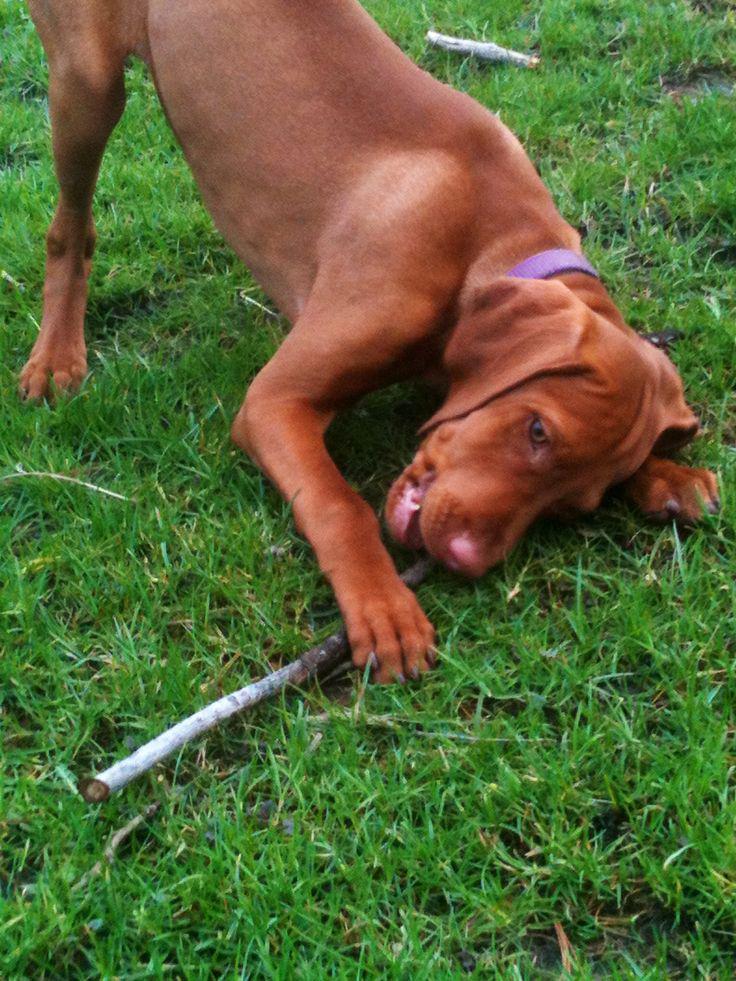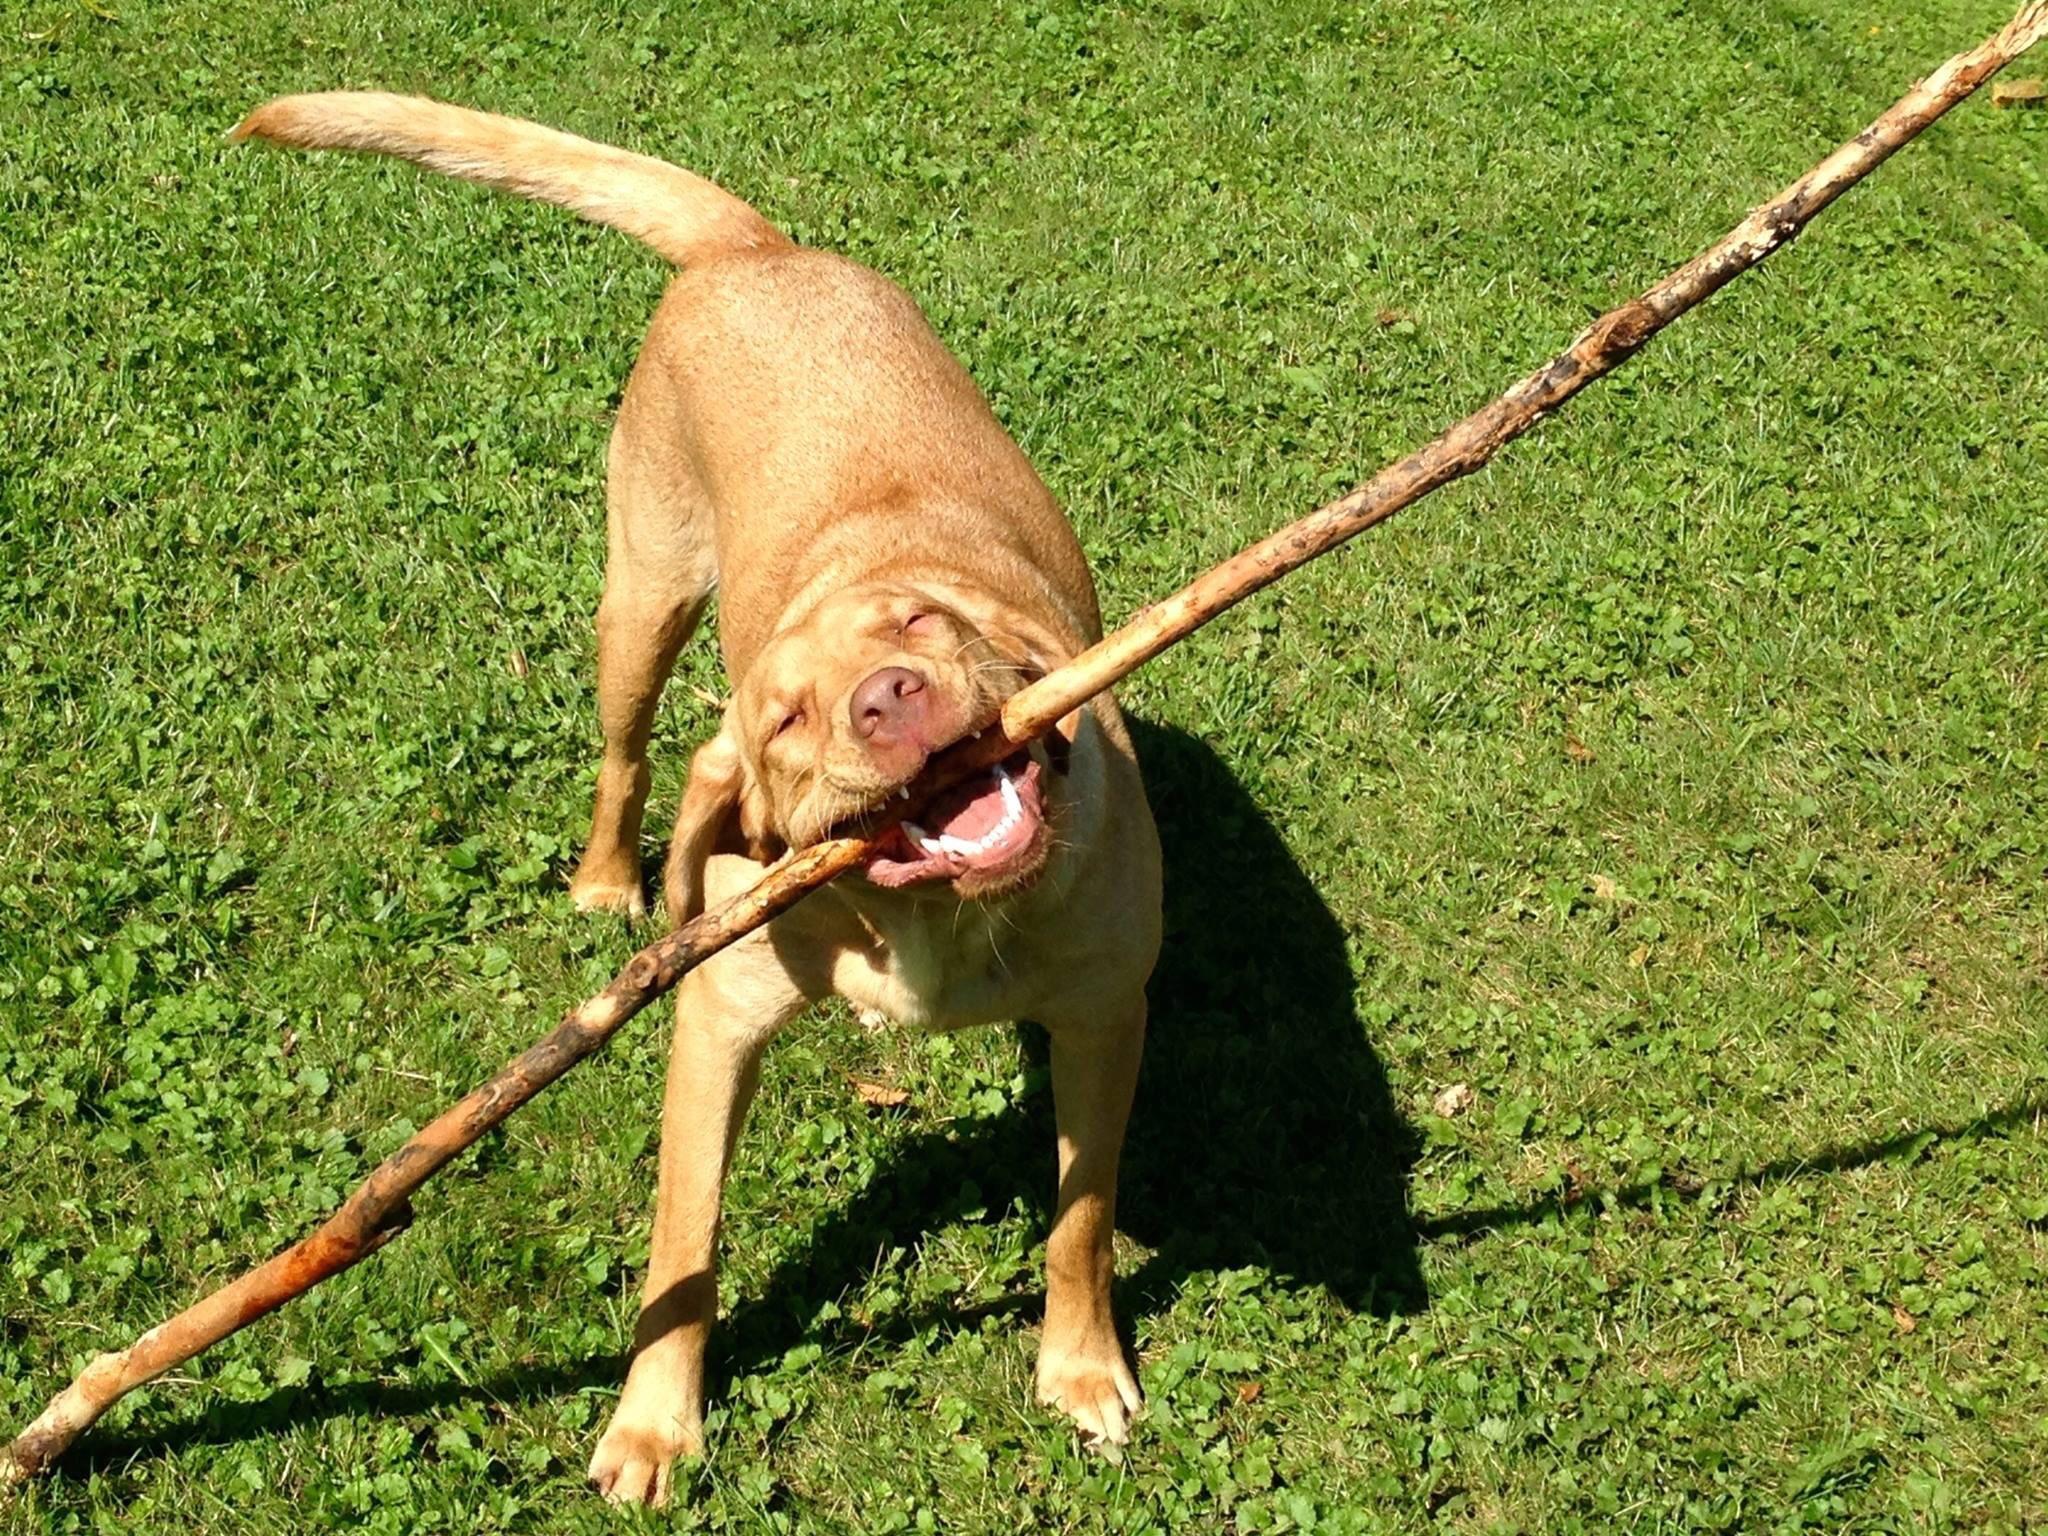The first image is the image on the left, the second image is the image on the right. Examine the images to the left and right. Is the description "In total, two dogs are outdoors with a wooden stick grasped in their mouth." accurate? Answer yes or no. Yes. The first image is the image on the left, the second image is the image on the right. Given the left and right images, does the statement "One dog is laying down." hold true? Answer yes or no. No. 